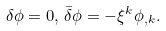<formula> <loc_0><loc_0><loc_500><loc_500>\delta \phi = 0 , \, \bar { \delta } \phi = - \xi ^ { k } \phi _ { , k } .</formula> 